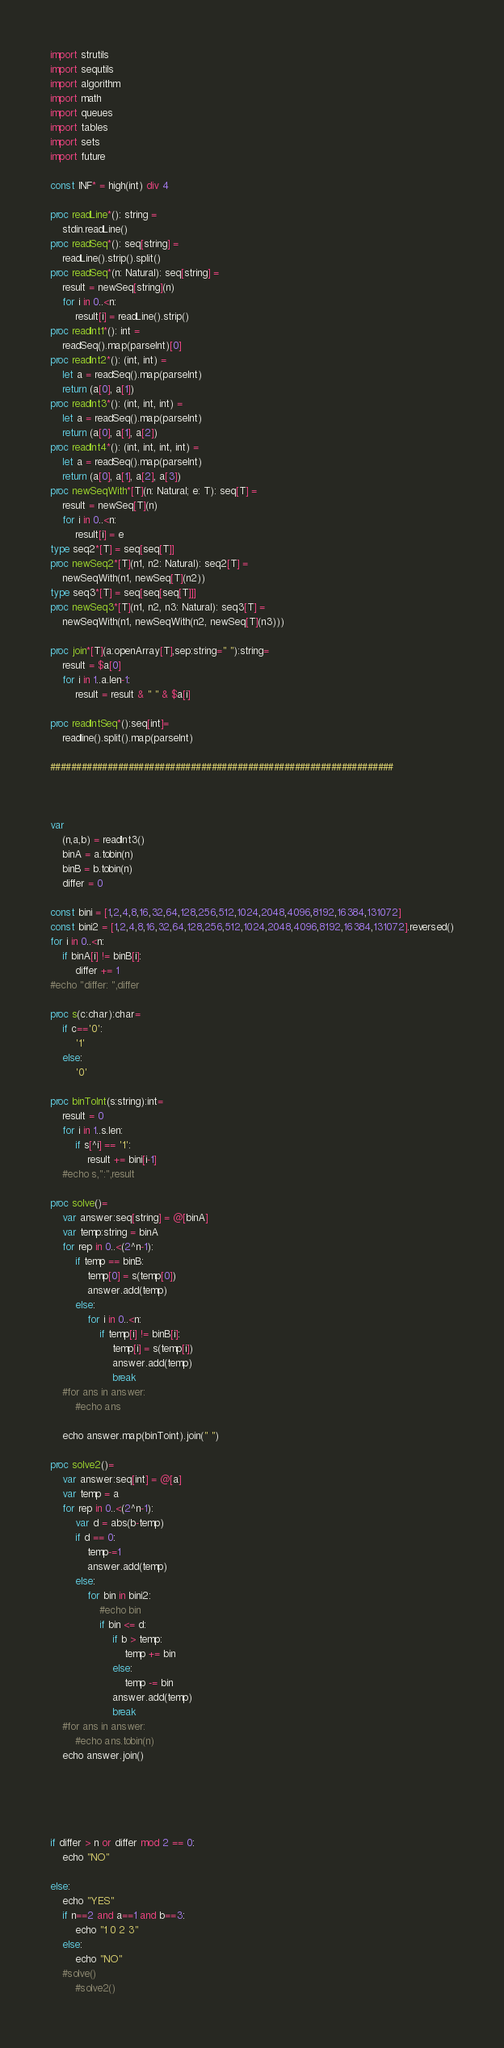<code> <loc_0><loc_0><loc_500><loc_500><_Nim_>import strutils
import sequtils
import algorithm
import math
import queues
import tables
import sets
import future
 
const INF* = high(int) div 4
 
proc readLine*(): string =
    stdin.readLine()
proc readSeq*(): seq[string] =
    readLine().strip().split()
proc readSeq*(n: Natural): seq[string] =
    result = newSeq[string](n)
    for i in 0..<n:
        result[i] = readLine().strip()
proc readInt1*(): int =
    readSeq().map(parseInt)[0]
proc readInt2*(): (int, int) =
    let a = readSeq().map(parseInt)
    return (a[0], a[1])
proc readInt3*(): (int, int, int) =
    let a = readSeq().map(parseInt)
    return (a[0], a[1], a[2])
proc readInt4*(): (int, int, int, int) =
    let a = readSeq().map(parseInt)
    return (a[0], a[1], a[2], a[3])
proc newSeqWith*[T](n: Natural; e: T): seq[T] =
    result = newSeq[T](n)
    for i in 0..<n:
        result[i] = e
type seq2*[T] = seq[seq[T]]
proc newSeq2*[T](n1, n2: Natural): seq2[T] =
    newSeqWith(n1, newSeq[T](n2))
type seq3*[T] = seq[seq[seq[T]]]
proc newSeq3*[T](n1, n2, n3: Natural): seq3[T] =
    newSeqWith(n1, newSeqWith(n2, newSeq[T](n3)))

proc join*[T](a:openArray[T],sep:string=" "):string=
    result = $a[0]
    for i in 1..a.len-1:
        result = result & " " & $a[i]

proc readIntSeq*():seq[int]=
    readline().split().map(parseInt)

##################################################################



var
    (n,a,b) = readInt3()
    binA = a.tobin(n)
    binB = b.tobin(n)
    differ = 0

const bini = [1,2,4,8,16,32,64,128,256,512,1024,2048,4096,8192,16384,131072]
const bini2 = [1,2,4,8,16,32,64,128,256,512,1024,2048,4096,8192,16384,131072].reversed()
for i in 0..<n:
    if binA[i] != binB[i]:
        differ += 1
#echo "differ: ",differ

proc s(c:char):char=
    if c=='0':
        '1'
    else:
        '0'

proc binToInt(s:string):int=
    result = 0
    for i in 1..s.len:
        if s[^i] == '1':
            result += bini[i-1]
    #echo s,":",result

proc solve()=
    var answer:seq[string] = @[binA]
    var temp:string = binA
    for rep in 0..<(2^n-1):
        if temp == binB:
            temp[0] = s(temp[0])
            answer.add(temp)
        else:
            for i in 0..<n:
                if temp[i] != binB[i]:
                    temp[i] = s(temp[i])
                    answer.add(temp)
                    break
    #for ans in answer:
        #echo ans

    echo answer.map(binToint).join(" ")
    
proc solve2()=
    var answer:seq[int] = @[a]
    var temp = a
    for rep in 0..<(2^n-1):
        var d = abs(b-temp)
        if d == 0:
            temp-=1
            answer.add(temp)
        else:
            for bin in bini2:
                #echo bin
                if bin <= d:
                    if b > temp:
                        temp += bin
                    else:
                        temp -= bin
                    answer.add(temp)
                    break
    #for ans in answer:
        #echo ans.tobin(n)
    echo answer.join()


            


if differ > n or differ mod 2 == 0:
    echo "NO"

else:
    echo "YES"
    if n==2 and a==1 and b==3:
        echo "1 0 2 3"
    else:
        echo "NO"
    #solve()
        #solve2()</code> 